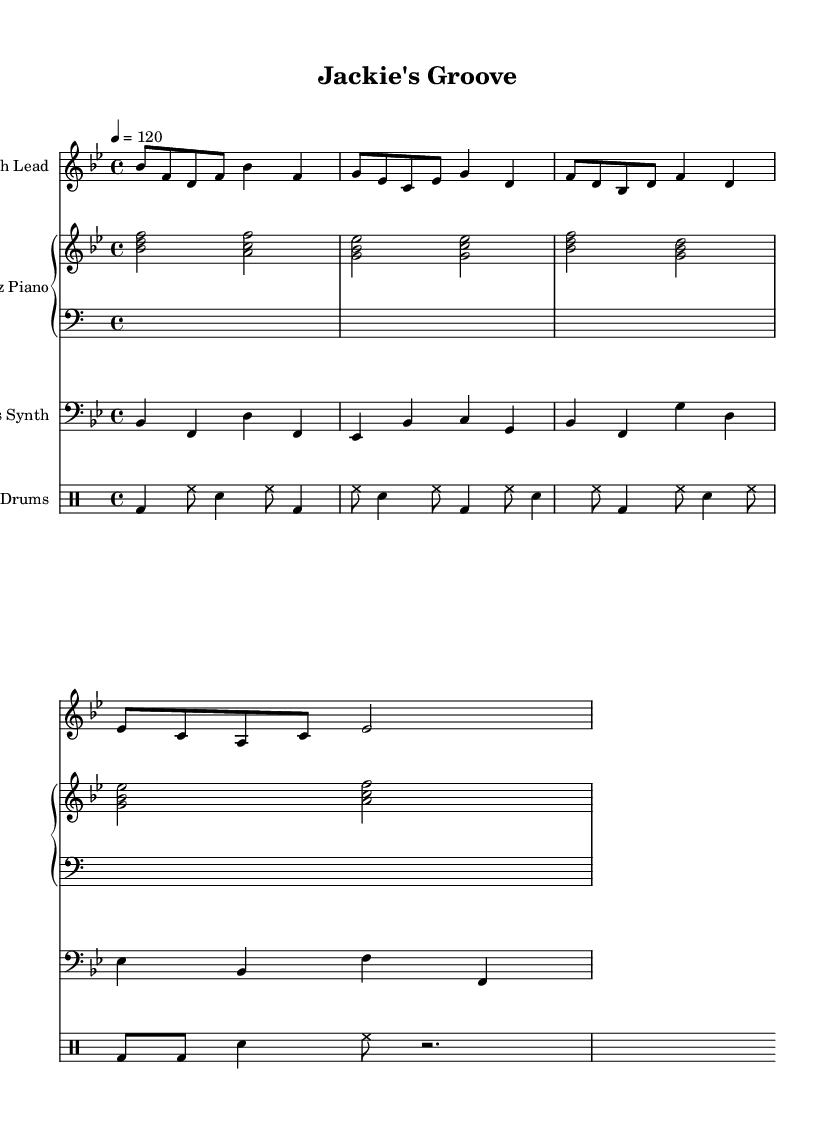What is the key signature of this music? The key signature is B flat major, indicated by the presence of two flats (B flat and E flat) in the key signature on the staff.
Answer: B flat major What is the time signature of this piece? The time signature is 4/4, shown at the beginning of the piece, which indicates that there are four beats in each measure and the quarter note gets one beat.
Answer: 4/4 What is the tempo marking for this track? The tempo marking is indicated at the beginning as "4 = 120", which means there are 120 beats per minute and the quarter note gets one beat.
Answer: 120 How many instruments are featured in this score? There are four instruments in total: Synth Lead, Jazz Piano, Bass Synth, and E. Drums as indicated by the separate staves for each.
Answer: Four Which instrument plays the bass line in this piece? The instrument that plays the bass line is the Bass Synth, as indicated by the staff labeled "Bass Synth" in the score.
Answer: Bass Synth What is the rhythmic pattern of the drums in the first measure? In the first measure, the rhythmic pattern consists of a bass drum on the first beat, hi-hat played on the second and third eighth notes, followed by a snare hit on the third beat, and another hi-hat on the fourth eighth note.
Answer: Bass, Hi-hat, Snare Which musical style elements are incorporated into this electronic track? The musical style elements include jazz chords and syncopated rhythms, which blend traditional jazz characteristics with modern electronic beats, creating a fusion of genres.
Answer: Jazz elements 